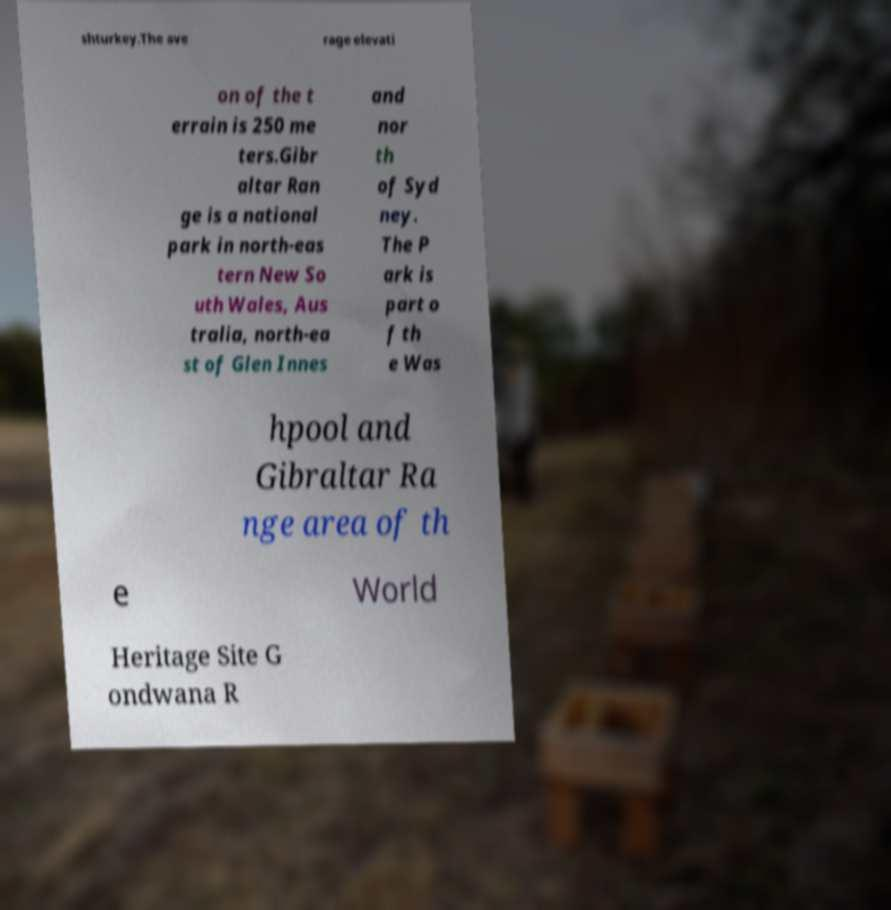Could you extract and type out the text from this image? shturkey.The ave rage elevati on of the t errain is 250 me ters.Gibr altar Ran ge is a national park in north-eas tern New So uth Wales, Aus tralia, north-ea st of Glen Innes and nor th of Syd ney. The P ark is part o f th e Was hpool and Gibraltar Ra nge area of th e World Heritage Site G ondwana R 